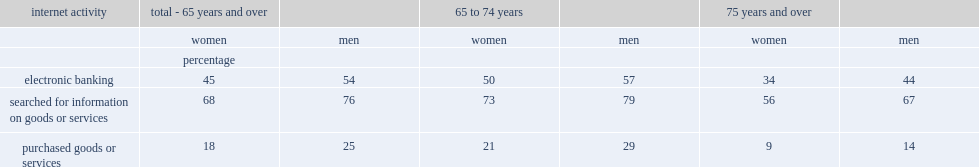What are the percentage of female and male internet users aged 65 and over reported that they had done electronic banking. 45.0 54.0. What are the percentages of senior women and senior men searching for information on goods or services. 68.0 76.0. Which was less likely to have made an online purchase,senior women or senior men. Women. Would you be able to parse every entry in this table? {'header': ['internet activity', 'total - 65 years and over', '', '65 to 74 years', '', '75 years and over', ''], 'rows': [['', 'women', 'men', 'women', 'men', 'women', 'men'], ['', 'percentage', '', '', '', '', ''], ['electronic banking', '45', '54', '50', '57', '34', '44'], ['searched for information on goods or services', '68', '76', '73', '79', '56', '67'], ['purchased goods or services', '18', '25', '21', '29', '9', '14']]} 